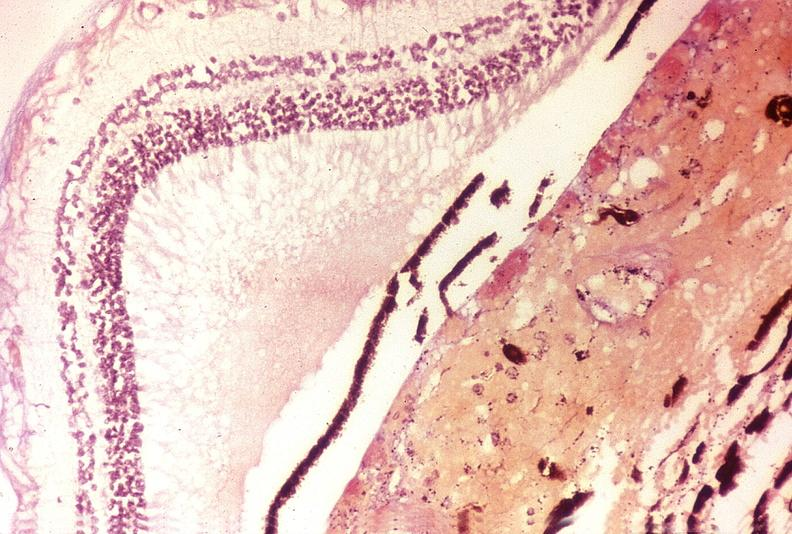what is present?
Answer the question using a single word or phrase. Eye 